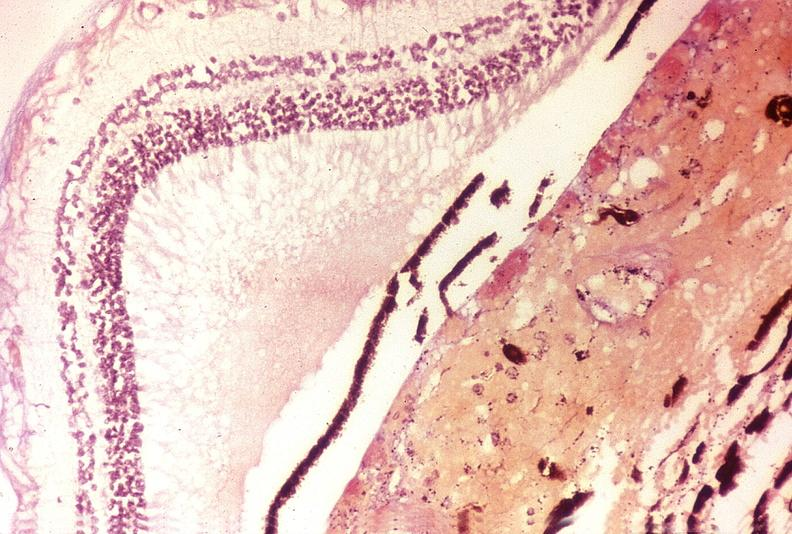what is present?
Answer the question using a single word or phrase. Eye 